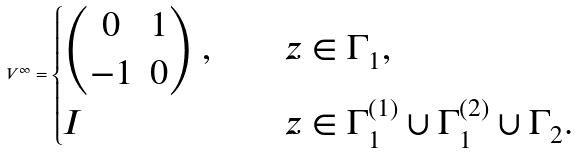<formula> <loc_0><loc_0><loc_500><loc_500>V ^ { \infty } = \begin{cases} \begin{pmatrix} 0 & 1 \\ - 1 & 0 \end{pmatrix} , \quad & z \in \Gamma _ { 1 } , \\ I \quad & z \in \Gamma _ { 1 } ^ { ( 1 ) } \cup \Gamma _ { 1 } ^ { ( 2 ) } \cup \Gamma _ { 2 } . \end{cases}</formula> 